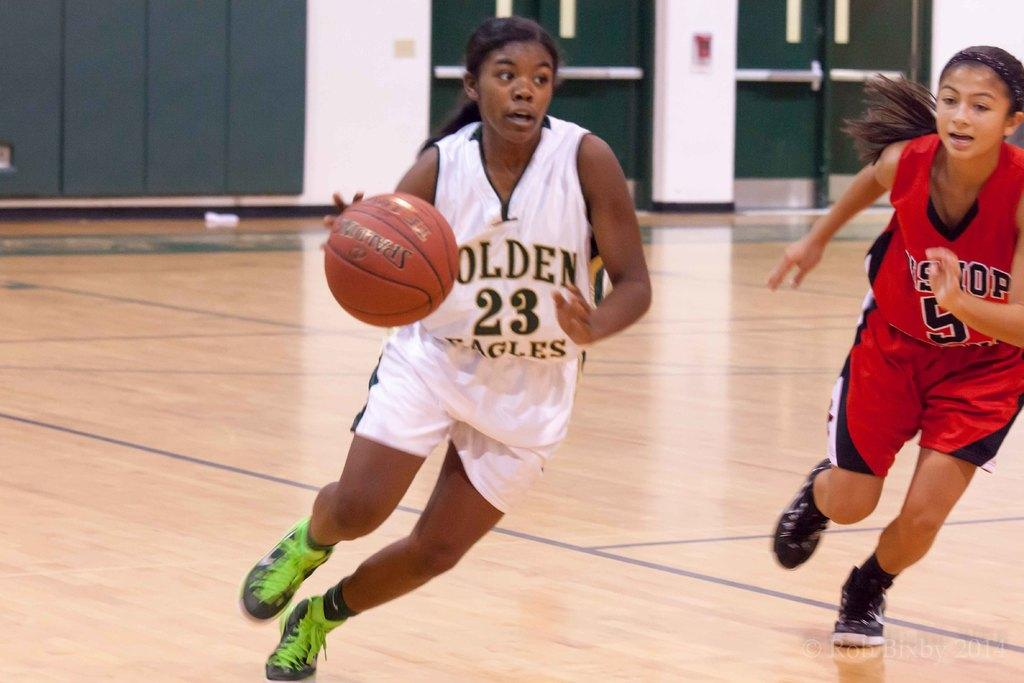<image>
Give a short and clear explanation of the subsequent image. A female basketball player for the Eagles runs down the court with the ball. 